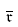Convert formula to latex. <formula><loc_0><loc_0><loc_500><loc_500>\overline { { \mathfrak { r } } }</formula> 